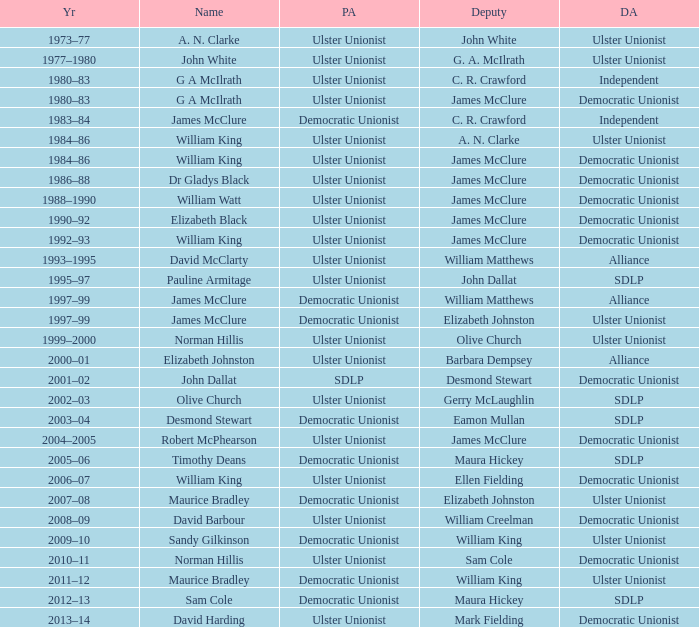What is the name of the deputy in 1992–93? James McClure. 